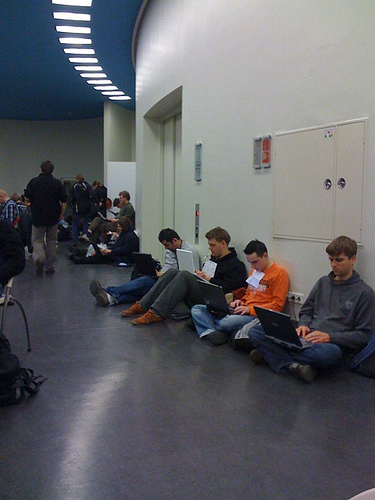<image>What clothing has a rip in it? It is ambiguous. The clothing that has a rip in it can be jeans or none. What clothing has a rip in it? There is no clothing with a rip in it. 